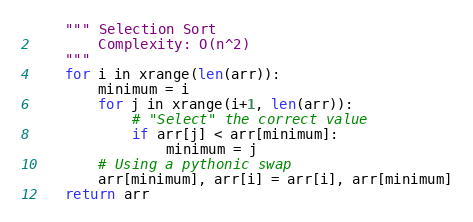Convert code to text. <code><loc_0><loc_0><loc_500><loc_500><_Python_>    """ Selection Sort
        Complexity: O(n^2)
    """
    for i in xrange(len(arr)):
        minimum = i
        for j in xrange(i+1, len(arr)):
            # "Select" the correct value
            if arr[j] < arr[minimum]:
                minimum = j
        # Using a pythonic swap
        arr[minimum], arr[i] = arr[i], arr[minimum]
    return arr


</code> 